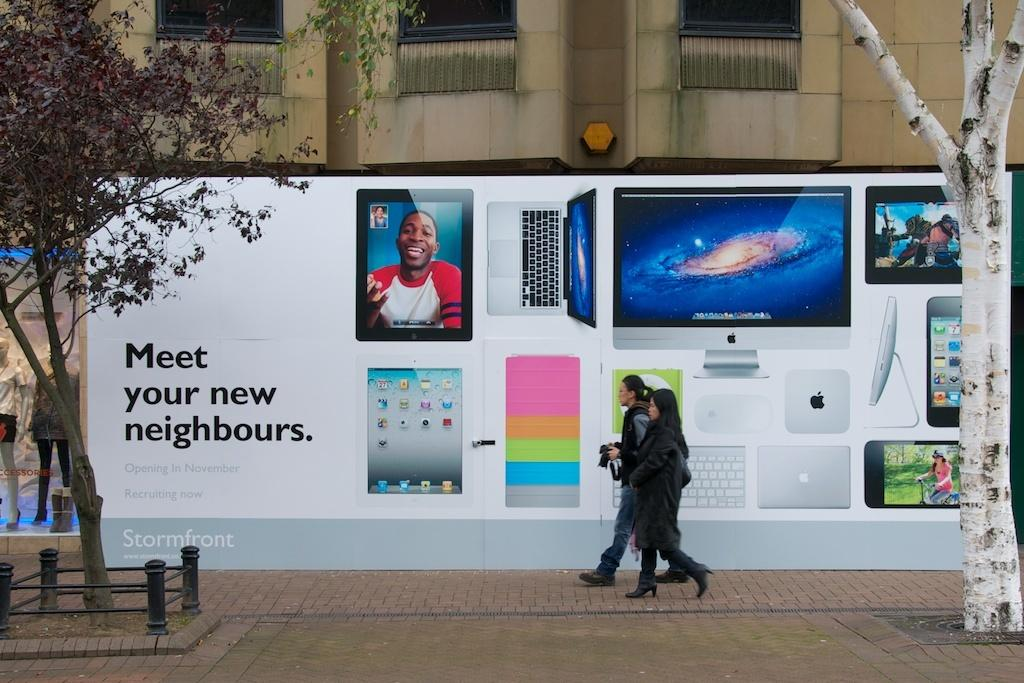<image>
Give a short and clear explanation of the subsequent image. Two women walking infront of a billboard that says Meet your new neighbours 